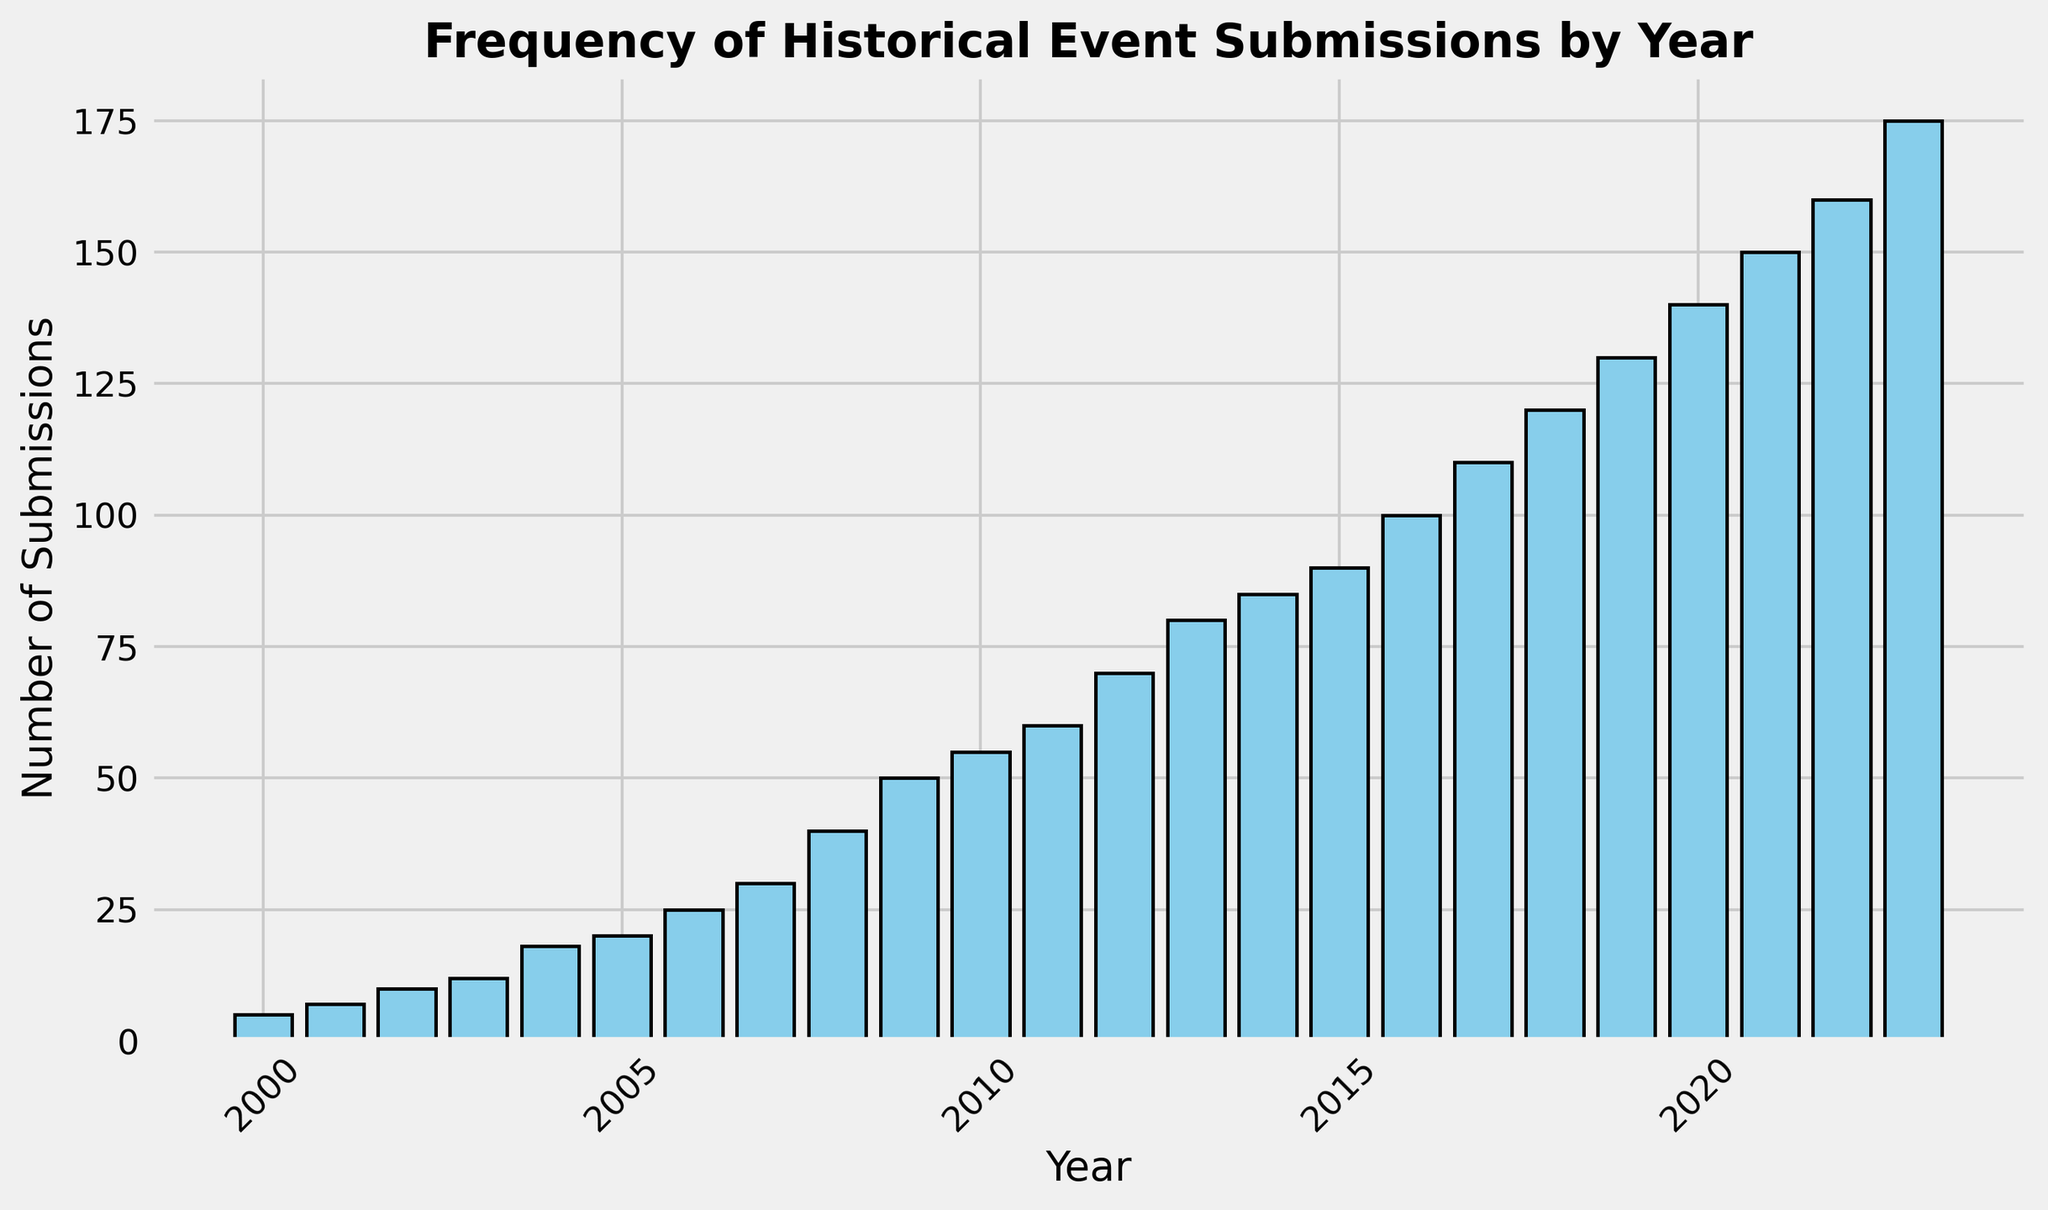What's the highest number of historical event submissions in any year? Identify the tallest bar in the histogram. The label on the x-axis for this bar corresponds to the year 2023, and the height represents the highest number of submissions.
Answer: 175 How many total submissions were there in 2020 and 2021? Identify the bars for the years 2020 and 2021. Sum the heights of these bars (140 from 2020 and 150 from 2021).
Answer: 290 Which year had a greater number of submissions, 2010 or 2011? Locate the bars for the years 2010 and 2011. Compare their heights; 2011's bar is taller than 2010’s.
Answer: 2011 What is the difference in the number of submissions between 2005 and 2006? Find the heights of the bars for the years 2005 (20 submissions) and 2006 (25 submissions). Subtract 20 from 25.
Answer: 5 What is the median number of submissions from 2000 to 2023? List all submission values in ascending order and find the middle value. For 24 data points, the median is the average of the 12th (60 submissions) and 13th (70 submissions) values. (60+70)/2 = 65
Answer: 65 Which year saw the first instance of submissions reaching or surpassing 100? Identify the first bar whose height reaches or exceeds 100 submissions, which corresponds to the year 2016.
Answer: 2016 How has the number of submissions changed between 2000 and 2023? Compare the height of the bar in 2000 (5 submissions) to that in 2023 (175 submissions). The number has increased significantly over the years.
Answer: Increased What is the average number of submissions per year from 2018 to 2023? Find the total number of submissions from 2018 to 2023 (120 + 130 + 140 + 150 + 160 + 175). Divide this by the number of years (6). (120 + 130 + 140 + 150 + 160 + 175) / 6 = 145.83
Answer: 145.83 Which decade saw the highest overall submissions? Sum up the submissions for the decade 2000-2009 and 2010-2019. Compare the totals. 2000-2009: (5+7+10+12+18+20+25+30+40+50)=217, 2010-2019: (55+60+70+80+85+90+100+110+120+130)=900. The latter is higher.
Answer: 2010-2019 What is the range of submissions between the year with the minimum and the year with the maximum submissions? Identify the years with the minimum (2000, 5 submissions) and maximum (2023, 175 submissions) submissions. Subtract the minimum from the maximum (175-5).
Answer: 170 